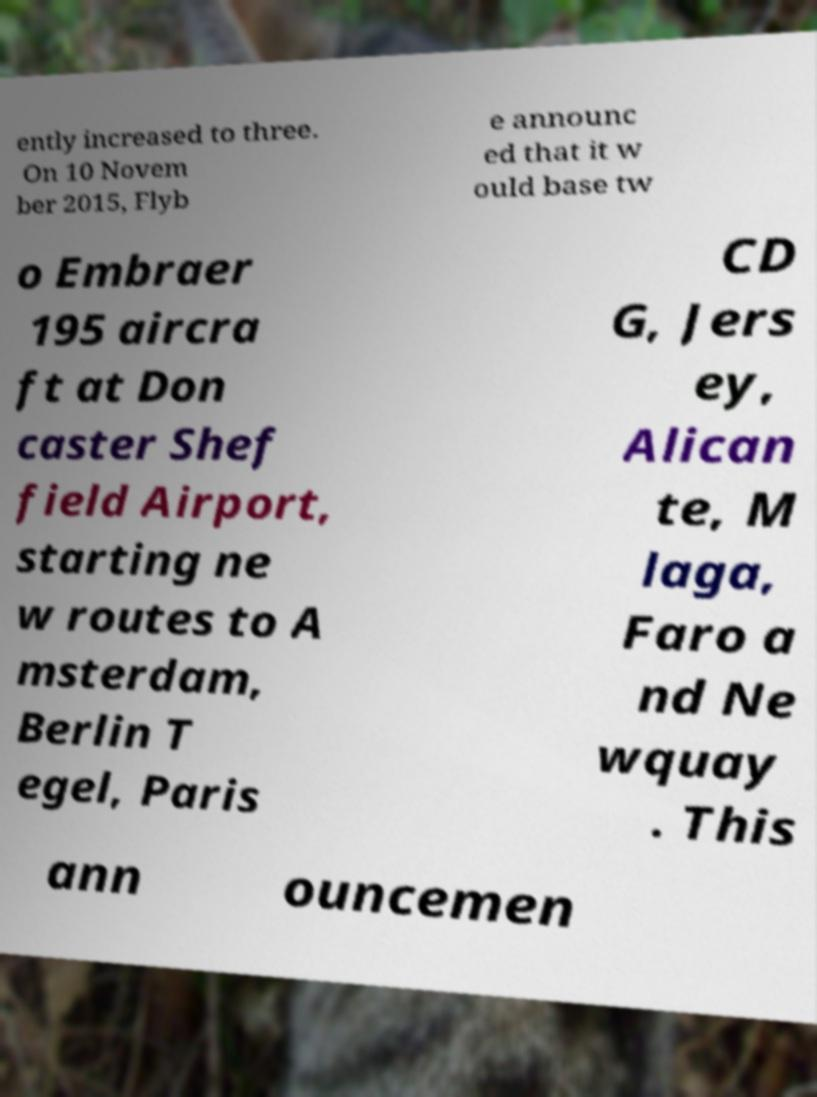I need the written content from this picture converted into text. Can you do that? ently increased to three. On 10 Novem ber 2015, Flyb e announc ed that it w ould base tw o Embraer 195 aircra ft at Don caster Shef field Airport, starting ne w routes to A msterdam, Berlin T egel, Paris CD G, Jers ey, Alican te, M laga, Faro a nd Ne wquay . This ann ouncemen 